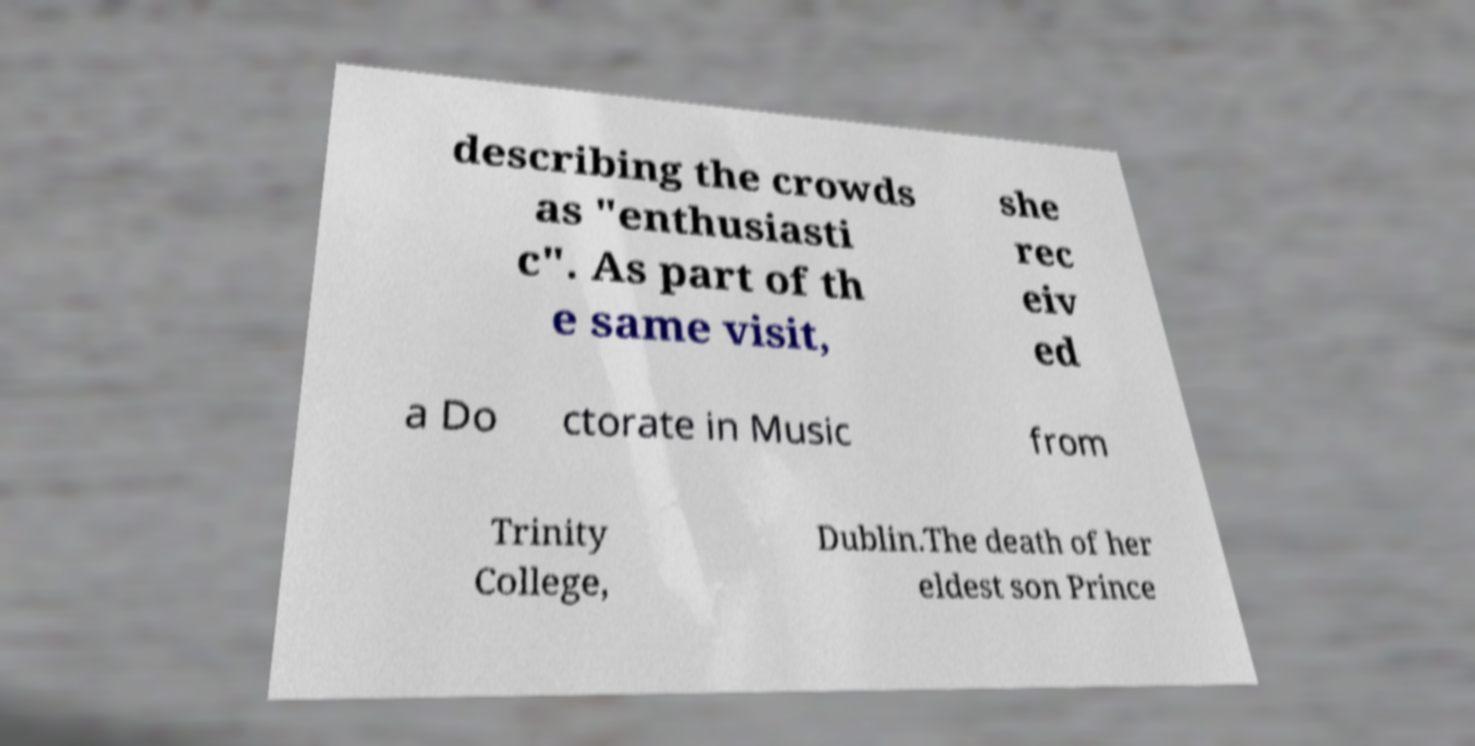Can you accurately transcribe the text from the provided image for me? describing the crowds as "enthusiasti c". As part of th e same visit, she rec eiv ed a Do ctorate in Music from Trinity College, Dublin.The death of her eldest son Prince 